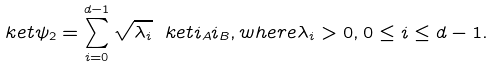Convert formula to latex. <formula><loc_0><loc_0><loc_500><loc_500>\ k e t { \psi _ { 2 } } = \sum _ { i = 0 } ^ { d - 1 } \sqrt { \lambda _ { i } } \ k e t { i _ { A } i _ { B } } , w h e r e \lambda _ { i } > 0 , 0 \leq i \leq d - 1 .</formula> 